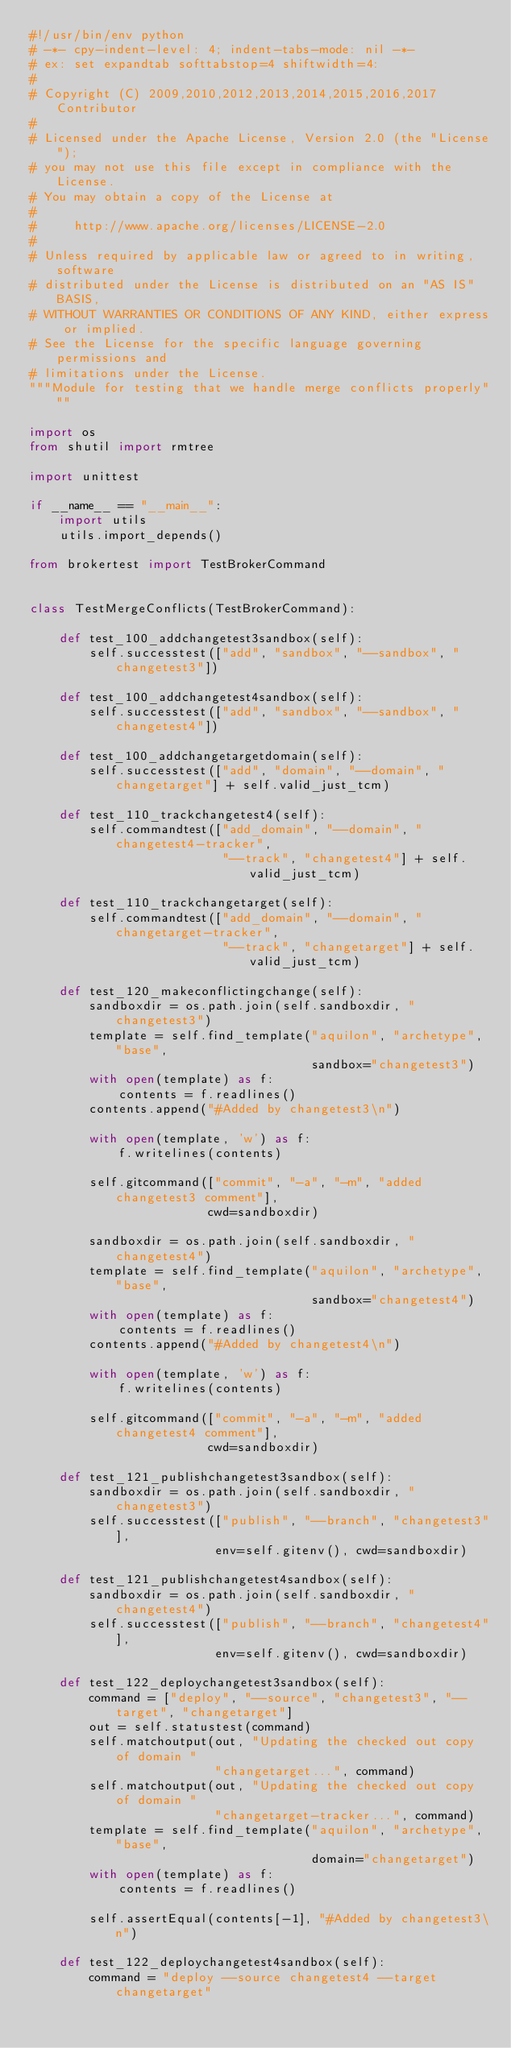<code> <loc_0><loc_0><loc_500><loc_500><_Python_>#!/usr/bin/env python
# -*- cpy-indent-level: 4; indent-tabs-mode: nil -*-
# ex: set expandtab softtabstop=4 shiftwidth=4:
#
# Copyright (C) 2009,2010,2012,2013,2014,2015,2016,2017  Contributor
#
# Licensed under the Apache License, Version 2.0 (the "License");
# you may not use this file except in compliance with the License.
# You may obtain a copy of the License at
#
#     http://www.apache.org/licenses/LICENSE-2.0
#
# Unless required by applicable law or agreed to in writing, software
# distributed under the License is distributed on an "AS IS" BASIS,
# WITHOUT WARRANTIES OR CONDITIONS OF ANY KIND, either express or implied.
# See the License for the specific language governing permissions and
# limitations under the License.
"""Module for testing that we handle merge conflicts properly"""

import os
from shutil import rmtree

import unittest

if __name__ == "__main__":
    import utils
    utils.import_depends()

from brokertest import TestBrokerCommand


class TestMergeConflicts(TestBrokerCommand):

    def test_100_addchangetest3sandbox(self):
        self.successtest(["add", "sandbox", "--sandbox", "changetest3"])

    def test_100_addchangetest4sandbox(self):
        self.successtest(["add", "sandbox", "--sandbox", "changetest4"])

    def test_100_addchangetargetdomain(self):
        self.successtest(["add", "domain", "--domain", "changetarget"] + self.valid_just_tcm)

    def test_110_trackchangetest4(self):
        self.commandtest(["add_domain", "--domain", "changetest4-tracker",
                          "--track", "changetest4"] + self.valid_just_tcm)

    def test_110_trackchangetarget(self):
        self.commandtest(["add_domain", "--domain", "changetarget-tracker",
                          "--track", "changetarget"] + self.valid_just_tcm)

    def test_120_makeconflictingchange(self):
        sandboxdir = os.path.join(self.sandboxdir, "changetest3")
        template = self.find_template("aquilon", "archetype", "base",
                                      sandbox="changetest3")
        with open(template) as f:
            contents = f.readlines()
        contents.append("#Added by changetest3\n")

        with open(template, 'w') as f:
            f.writelines(contents)

        self.gitcommand(["commit", "-a", "-m", "added changetest3 comment"],
                        cwd=sandboxdir)

        sandboxdir = os.path.join(self.sandboxdir, "changetest4")
        template = self.find_template("aquilon", "archetype", "base",
                                      sandbox="changetest4")
        with open(template) as f:
            contents = f.readlines()
        contents.append("#Added by changetest4\n")

        with open(template, 'w') as f:
            f.writelines(contents)

        self.gitcommand(["commit", "-a", "-m", "added changetest4 comment"],
                        cwd=sandboxdir)

    def test_121_publishchangetest3sandbox(self):
        sandboxdir = os.path.join(self.sandboxdir, "changetest3")
        self.successtest(["publish", "--branch", "changetest3"],
                         env=self.gitenv(), cwd=sandboxdir)

    def test_121_publishchangetest4sandbox(self):
        sandboxdir = os.path.join(self.sandboxdir, "changetest4")
        self.successtest(["publish", "--branch", "changetest4"],
                         env=self.gitenv(), cwd=sandboxdir)

    def test_122_deploychangetest3sandbox(self):
        command = ["deploy", "--source", "changetest3", "--target", "changetarget"]
        out = self.statustest(command)
        self.matchoutput(out, "Updating the checked out copy of domain "
                         "changetarget...", command)
        self.matchoutput(out, "Updating the checked out copy of domain "
                         "changetarget-tracker...", command)
        template = self.find_template("aquilon", "archetype", "base",
                                      domain="changetarget")
        with open(template) as f:
            contents = f.readlines()

        self.assertEqual(contents[-1], "#Added by changetest3\n")

    def test_122_deploychangetest4sandbox(self):
        command = "deploy --source changetest4 --target changetarget"</code> 